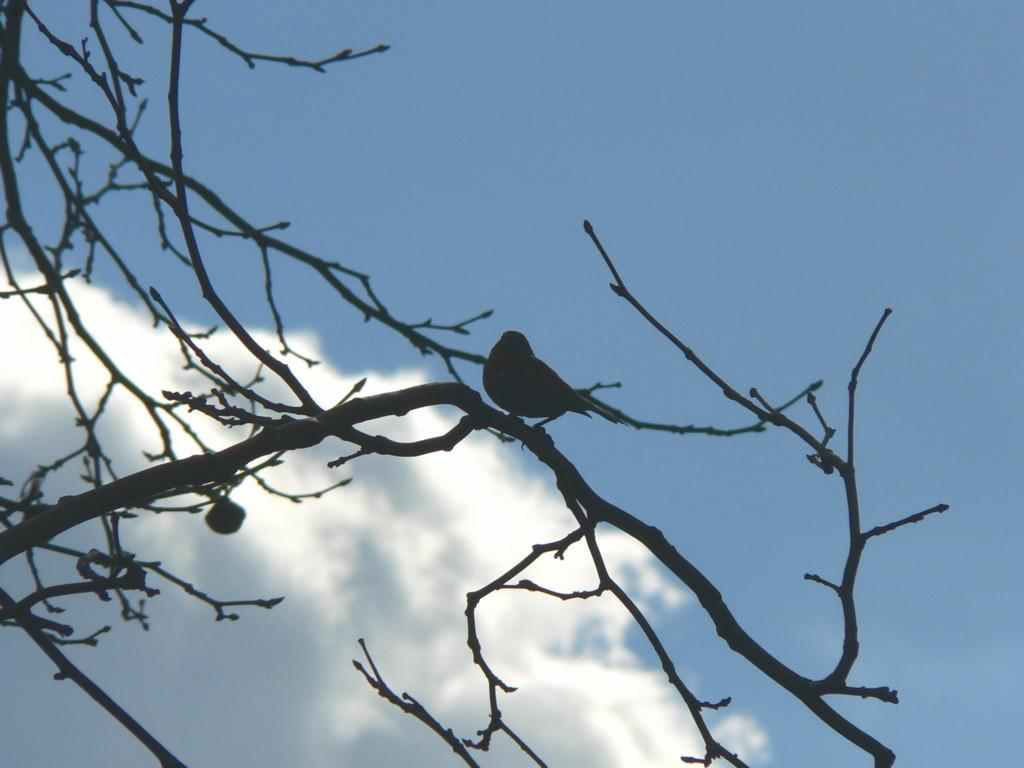What type of animal is present in the image? There is a bird in the image. Where is the bird located in the image? The bird is sitting on stems. What part of the natural environment is visible in the image? The sky is visible in the image. What type of cobweb can be seen in the image? There is no cobweb present in the image. What type of structure is visible in the image? The image does not show any structures; it features a bird sitting on stems with the sky visible in the background. 